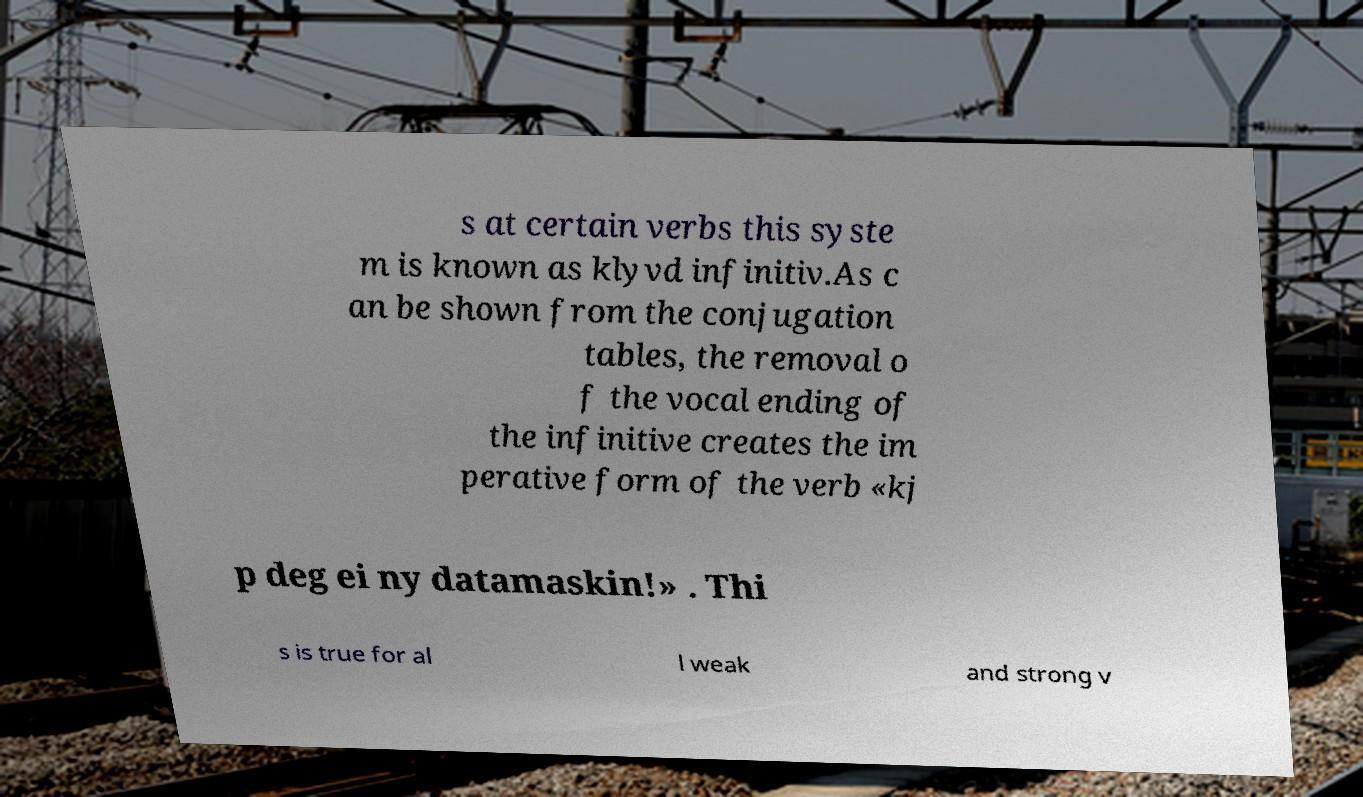For documentation purposes, I need the text within this image transcribed. Could you provide that? s at certain verbs this syste m is known as klyvd infinitiv.As c an be shown from the conjugation tables, the removal o f the vocal ending of the infinitive creates the im perative form of the verb «kj p deg ei ny datamaskin!» . Thi s is true for al l weak and strong v 